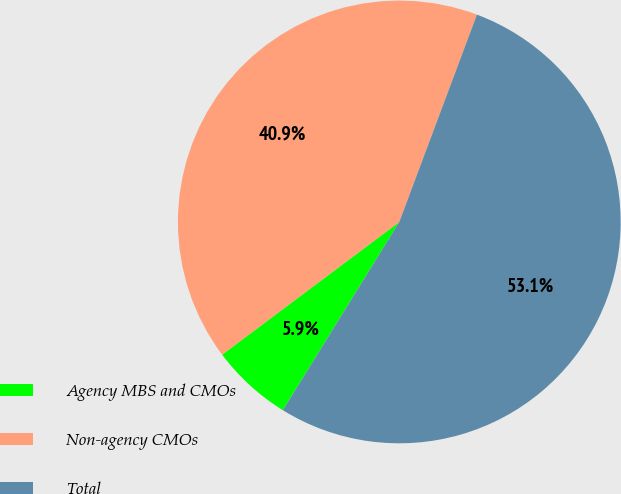Convert chart to OTSL. <chart><loc_0><loc_0><loc_500><loc_500><pie_chart><fcel>Agency MBS and CMOs<fcel>Non-agency CMOs<fcel>Total<nl><fcel>5.95%<fcel>40.94%<fcel>53.12%<nl></chart> 